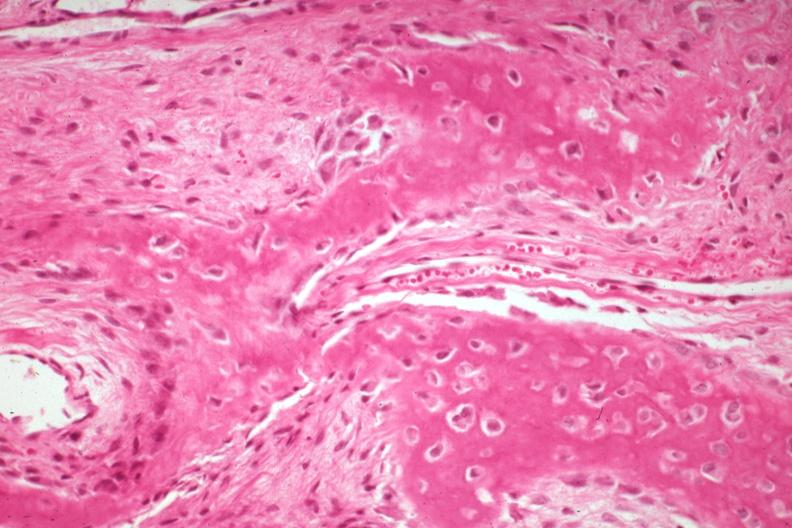what does this image show?
Answer the question using a single word or phrase. High excellent enchondral bone formation with osteoid osteoblasts osteoclasts 